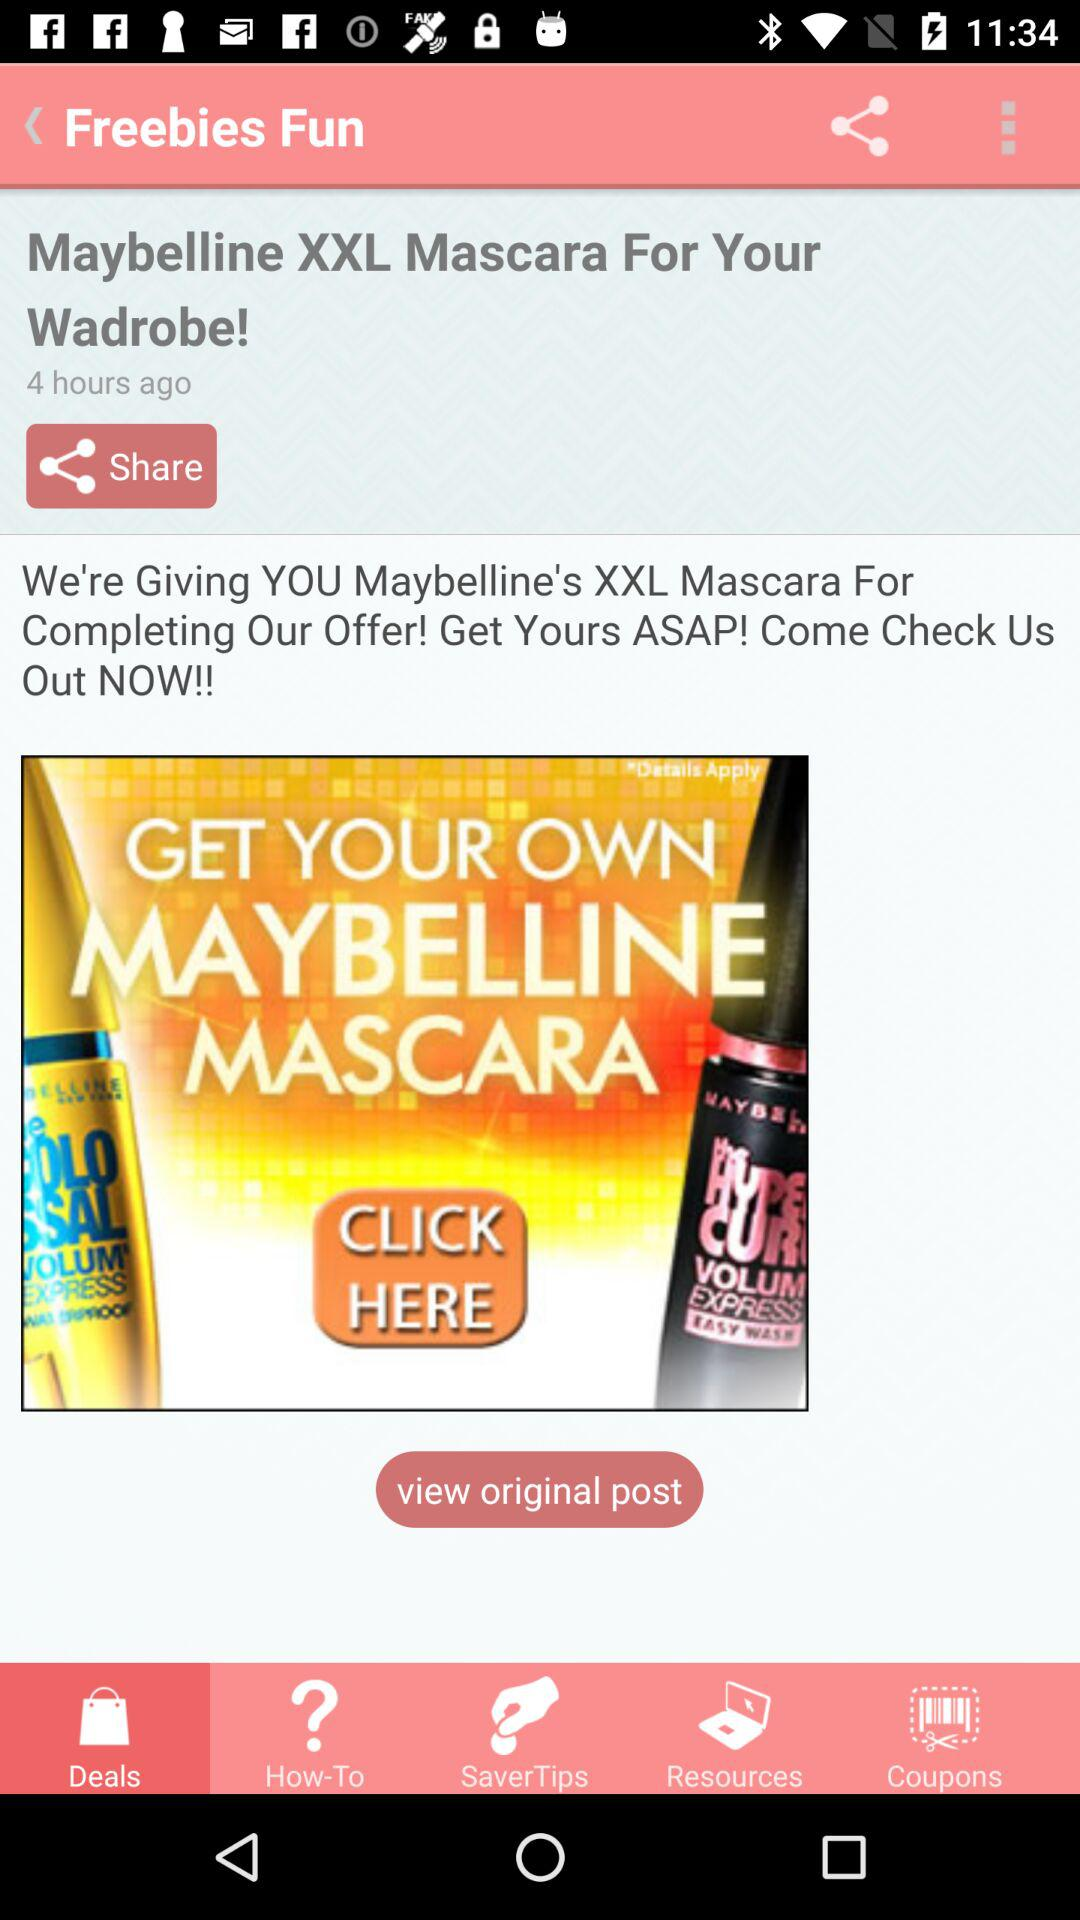How many hours ago was the post created?
Answer the question using a single word or phrase. 4 